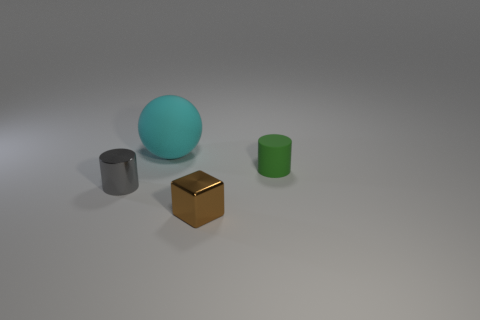Are the cylinder right of the large cyan thing and the tiny thing in front of the gray metal object made of the same material?
Ensure brevity in your answer.  No. The other big object that is the same material as the green object is what shape?
Keep it short and to the point. Sphere. Is there any other thing that has the same color as the tiny metallic block?
Offer a terse response. No. What number of tiny metal cylinders are there?
Provide a short and direct response. 1. What shape is the thing that is both on the left side of the small shiny cube and behind the tiny gray object?
Give a very brief answer. Sphere. There is a object that is behind the cylinder behind the small metal thing that is to the left of the cyan thing; what is its shape?
Provide a succinct answer. Sphere. There is a object that is behind the small gray thing and in front of the sphere; what material is it?
Provide a short and direct response. Rubber. What number of gray metal cylinders have the same size as the cyan sphere?
Your response must be concise. 0. What number of rubber things are either cyan balls or small blue cubes?
Your answer should be very brief. 1. What material is the big sphere?
Ensure brevity in your answer.  Rubber. 